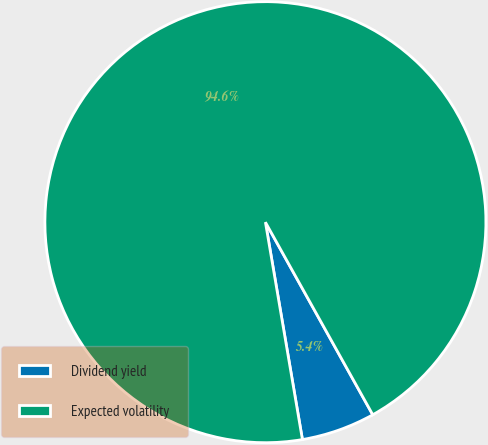Convert chart to OTSL. <chart><loc_0><loc_0><loc_500><loc_500><pie_chart><fcel>Dividend yield<fcel>Expected volatility<nl><fcel>5.41%<fcel>94.59%<nl></chart> 